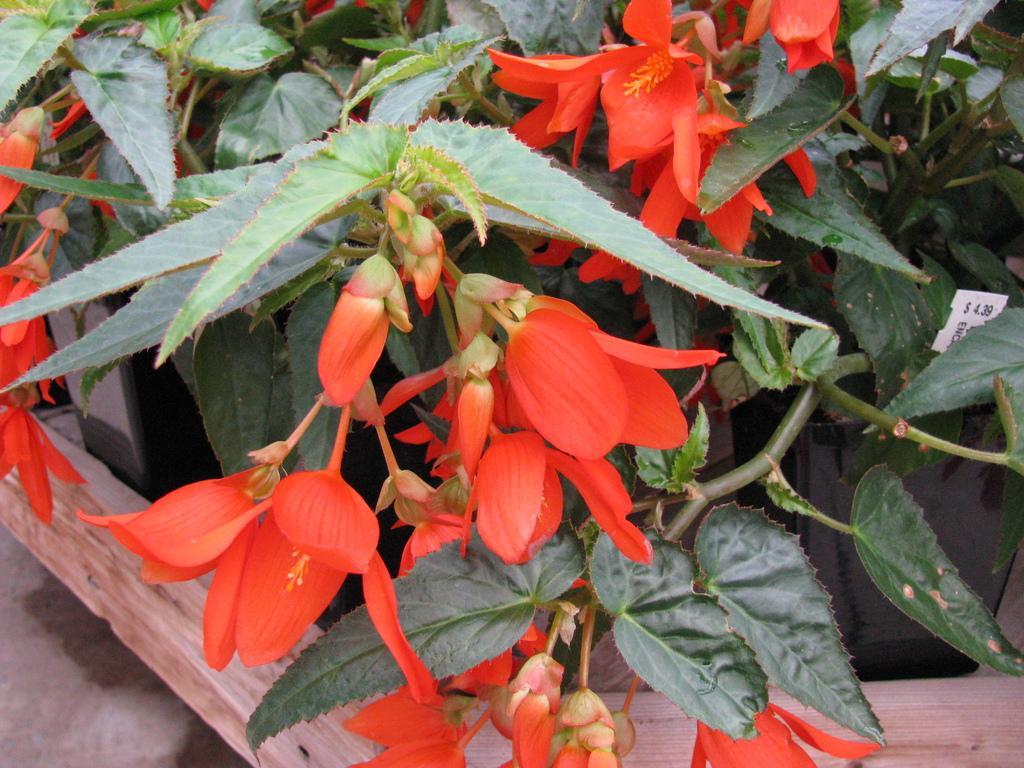Could you give a brief overview of what you see in this image? In the middle of the image there is a pot with a plant in it. There are a few flowers which are red in color and there are a few green leaves. 